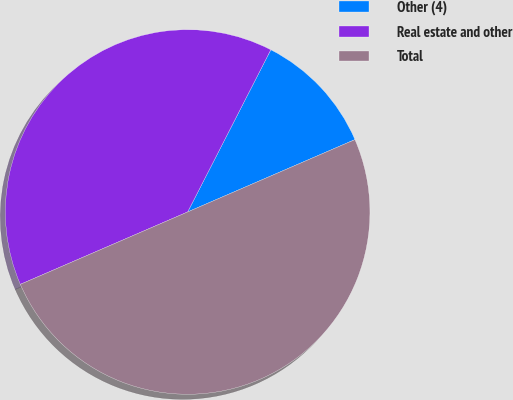Convert chart. <chart><loc_0><loc_0><loc_500><loc_500><pie_chart><fcel>Other (4)<fcel>Real estate and other<fcel>Total<nl><fcel>10.96%<fcel>39.04%<fcel>50.0%<nl></chart> 